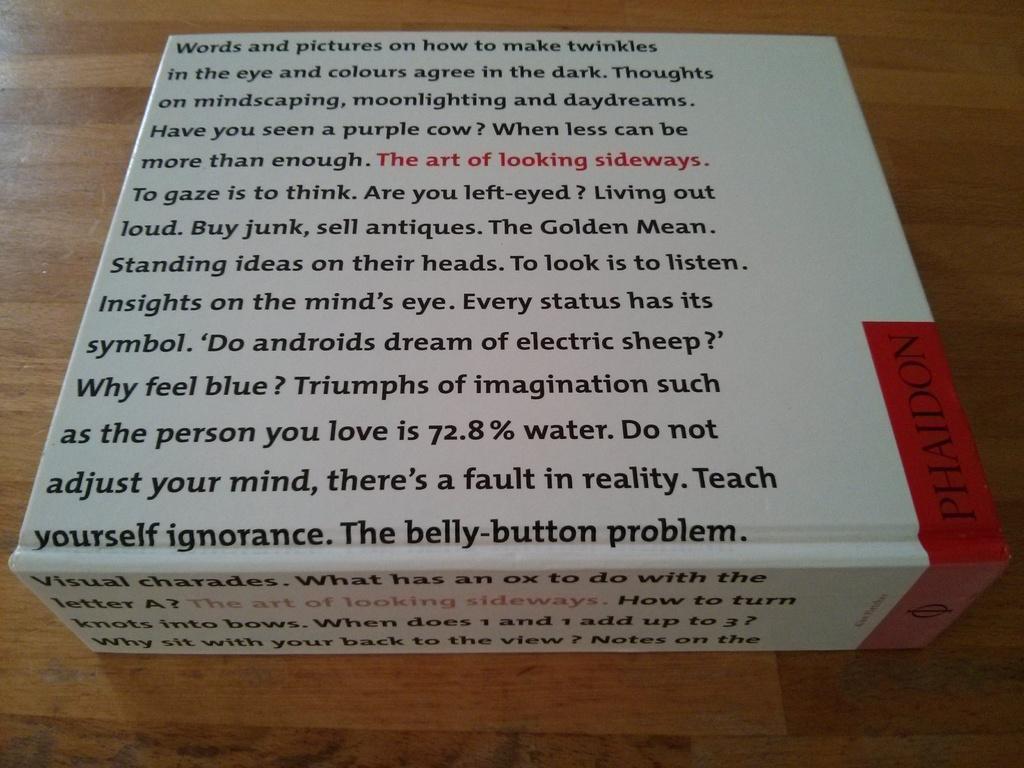Can you describe this image briefly? In the image we can see there is a box kept on the table and there is writing on it. 